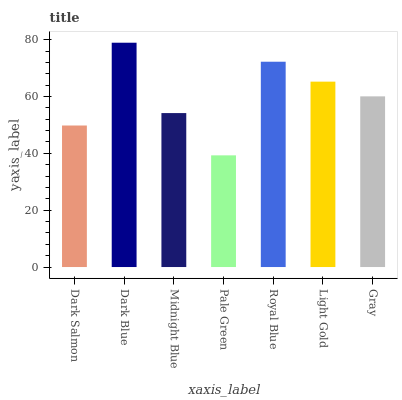Is Pale Green the minimum?
Answer yes or no. Yes. Is Dark Blue the maximum?
Answer yes or no. Yes. Is Midnight Blue the minimum?
Answer yes or no. No. Is Midnight Blue the maximum?
Answer yes or no. No. Is Dark Blue greater than Midnight Blue?
Answer yes or no. Yes. Is Midnight Blue less than Dark Blue?
Answer yes or no. Yes. Is Midnight Blue greater than Dark Blue?
Answer yes or no. No. Is Dark Blue less than Midnight Blue?
Answer yes or no. No. Is Gray the high median?
Answer yes or no. Yes. Is Gray the low median?
Answer yes or no. Yes. Is Midnight Blue the high median?
Answer yes or no. No. Is Pale Green the low median?
Answer yes or no. No. 